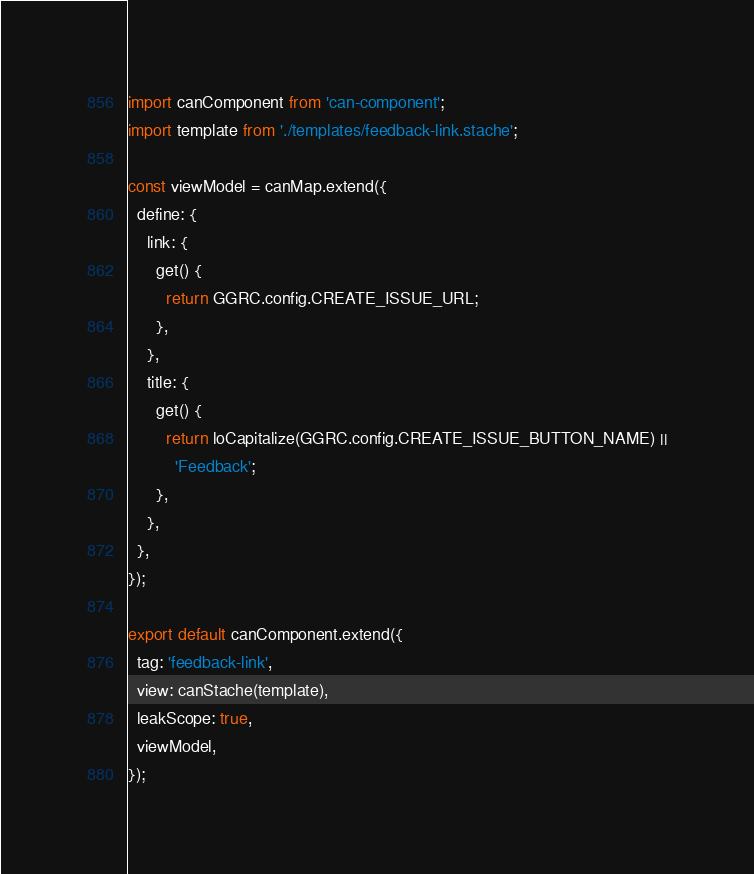Convert code to text. <code><loc_0><loc_0><loc_500><loc_500><_JavaScript_>import canComponent from 'can-component';
import template from './templates/feedback-link.stache';

const viewModel = canMap.extend({
  define: {
    link: {
      get() {
        return GGRC.config.CREATE_ISSUE_URL;
      },
    },
    title: {
      get() {
        return loCapitalize(GGRC.config.CREATE_ISSUE_BUTTON_NAME) ||
          'Feedback';
      },
    },
  },
});

export default canComponent.extend({
  tag: 'feedback-link',
  view: canStache(template),
  leakScope: true,
  viewModel,
});
</code> 